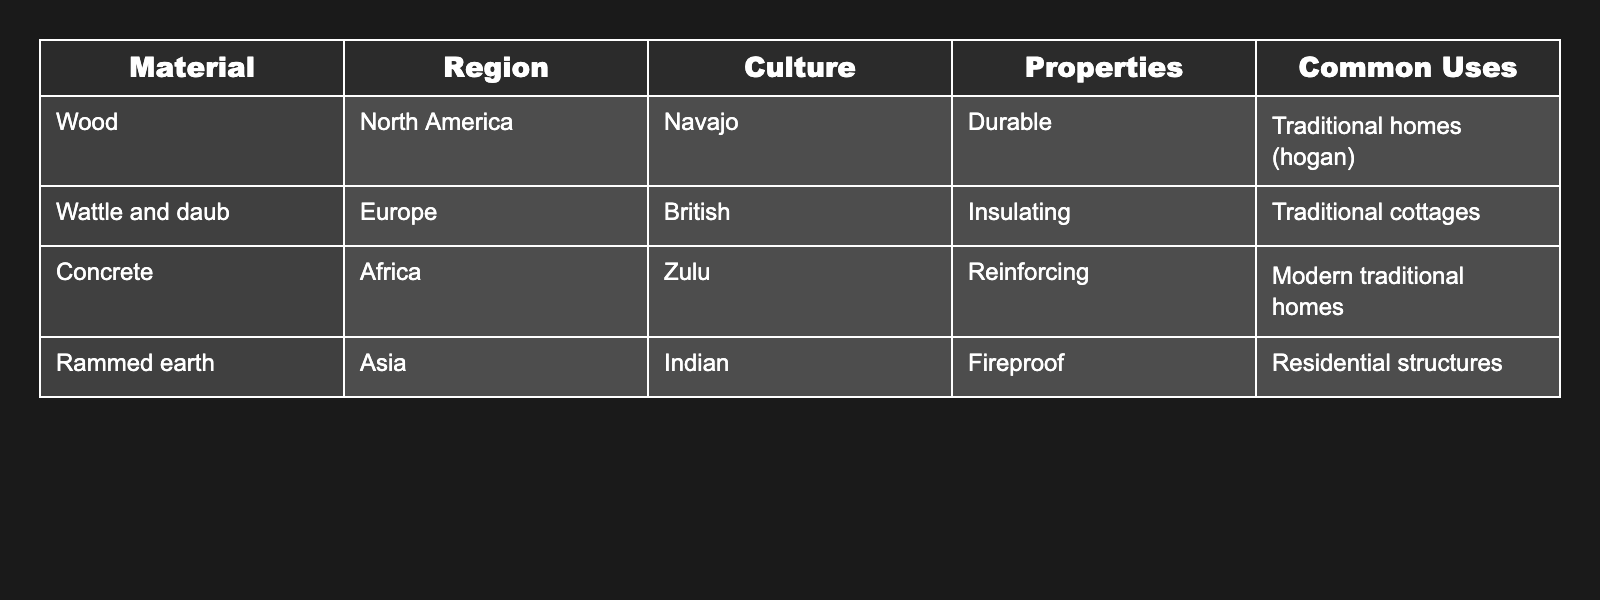What type of material is commonly used in Navajo traditional homes? The table includes a row for the Navajo culture, which indicates that wood is the material used for traditional homes like hogan.
Answer: Wood Which region utilizes concrete in their traditional homes? The table shows that concrete is used in the African region, specifically by the Zulu culture.
Answer: Africa Is rammed earth fireproof according to the table? The table clearly states that rammed earth has fireproof properties as denoted in its properties column.
Answer: Yes Are there any materials listed in the table that are used in both traditional and modern homes? The table mentions concrete as being used in modern traditional homes in Africa, thus indicating it straddles both categories.
Answer: Yes What is the common use of wattle and daub? By looking at the table, it states that wattle and daub is primarily used in traditional cottages, as shown in its common uses.
Answer: Traditional cottages Which material is listed in the table as having insulating properties? The properties column shows that wattle and daub is the material with insulating properties according to the British culture.
Answer: Wattle and daub Which culture in Asia uses rammed earth for residential structures? The table specifies that the Indian culture uses rammed earth for their residential structures as stated in the region and culture columns.
Answer: Indian How many materials in the table are used for residential structures? The table outlines that rammed earth is explicitly noted for residential structures, which is the only material with that designation, giving us a total of 1 material used for this purpose.
Answer: 1 What is the primary building material used by the British and what is its property? Referring to the table, the British culture uses wattle and daub, which is known for its insulating property.
Answer: Wattle and daub, Insulating Do any materials listed in the table have a property that emphasizes strength? The table identifies concrete as reinforcing, which specifies a property emphasizing strength, thus confirming the presence of such a material.
Answer: Yes, concrete 